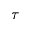<formula> <loc_0><loc_0><loc_500><loc_500>\tau</formula> 